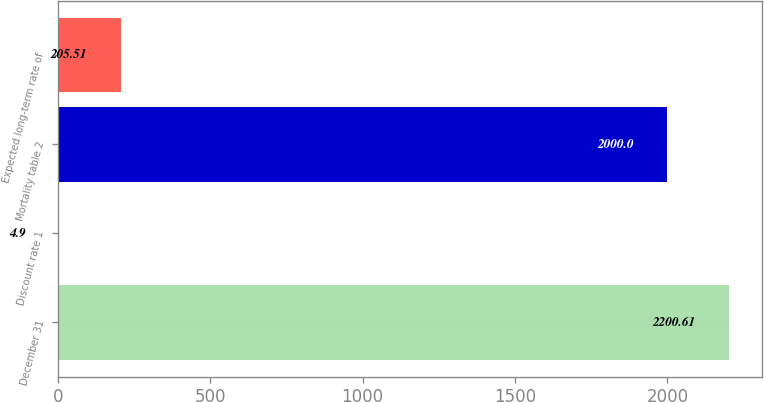Convert chart. <chart><loc_0><loc_0><loc_500><loc_500><bar_chart><fcel>December 31<fcel>Discount rate 1<fcel>Mortality table 2<fcel>Expected long-term rate of<nl><fcel>2200.61<fcel>4.9<fcel>2000<fcel>205.51<nl></chart> 